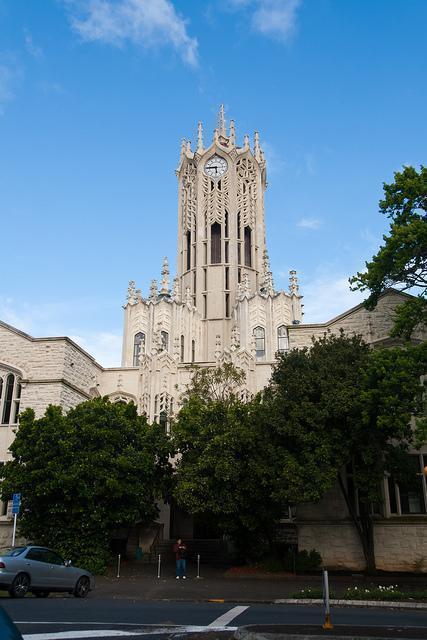What country is this building in?
Indicate the correct response by choosing from the four available options to answer the question.
Options: Australia, england, china, russia. Australia. 